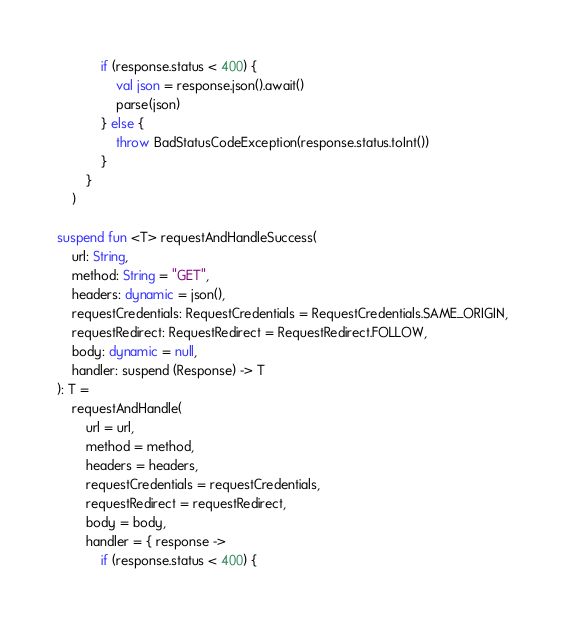<code> <loc_0><loc_0><loc_500><loc_500><_Kotlin_>            if (response.status < 400) {
                val json = response.json().await()
                parse(json)
            } else {
                throw BadStatusCodeException(response.status.toInt())
            }
        }
    )

suspend fun <T> requestAndHandleSuccess(
    url: String,
    method: String = "GET",
    headers: dynamic = json(),
    requestCredentials: RequestCredentials = RequestCredentials.SAME_ORIGIN,
    requestRedirect: RequestRedirect = RequestRedirect.FOLLOW,
    body: dynamic = null,
    handler: suspend (Response) -> T
): T =
    requestAndHandle(
        url = url,
        method = method,
        headers = headers,
        requestCredentials = requestCredentials,
        requestRedirect = requestRedirect,
        body = body,
        handler = { response ->
            if (response.status < 400) {</code> 